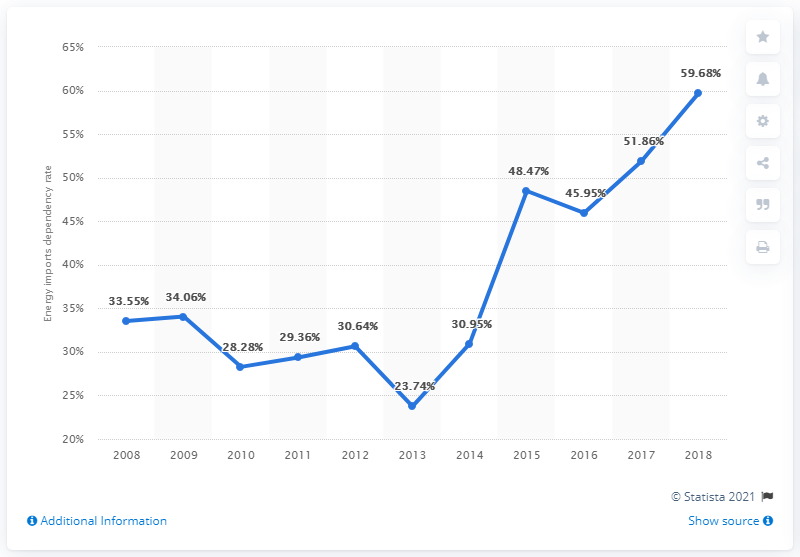Highlight a few significant elements in this photo. The median of the last three years is 51.86. In 2018, imports reached the highest level among all years. 